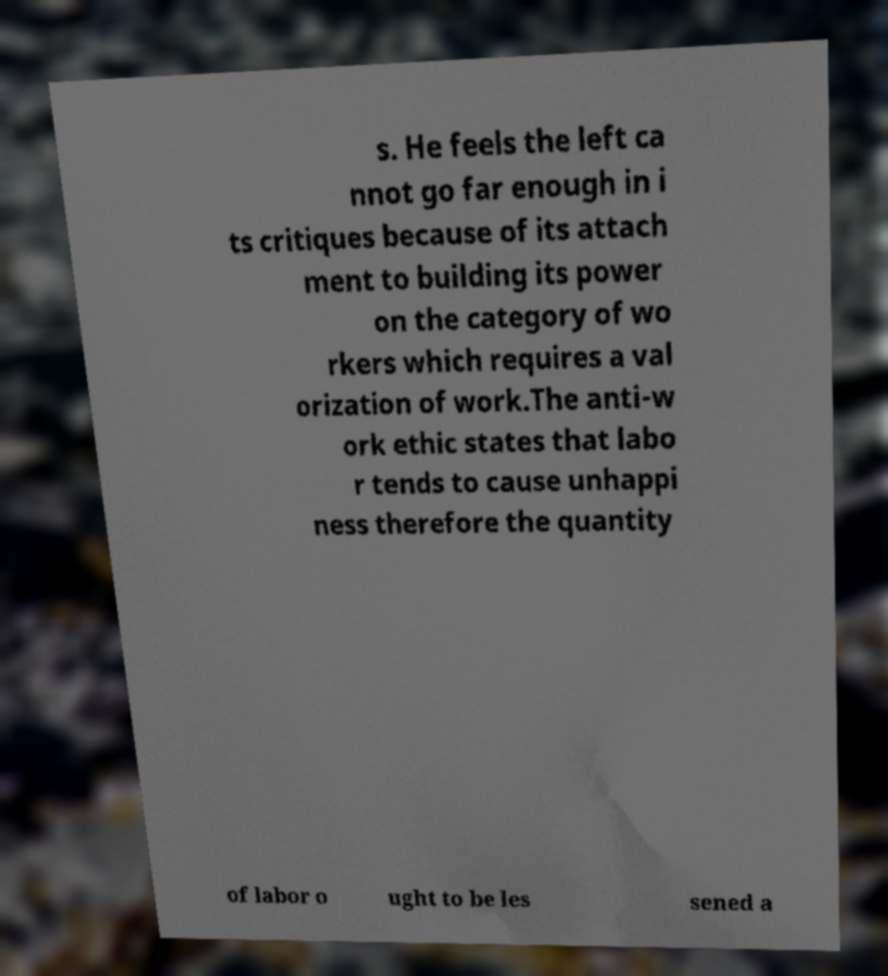For documentation purposes, I need the text within this image transcribed. Could you provide that? s. He feels the left ca nnot go far enough in i ts critiques because of its attach ment to building its power on the category of wo rkers which requires a val orization of work.The anti-w ork ethic states that labo r tends to cause unhappi ness therefore the quantity of labor o ught to be les sened a 